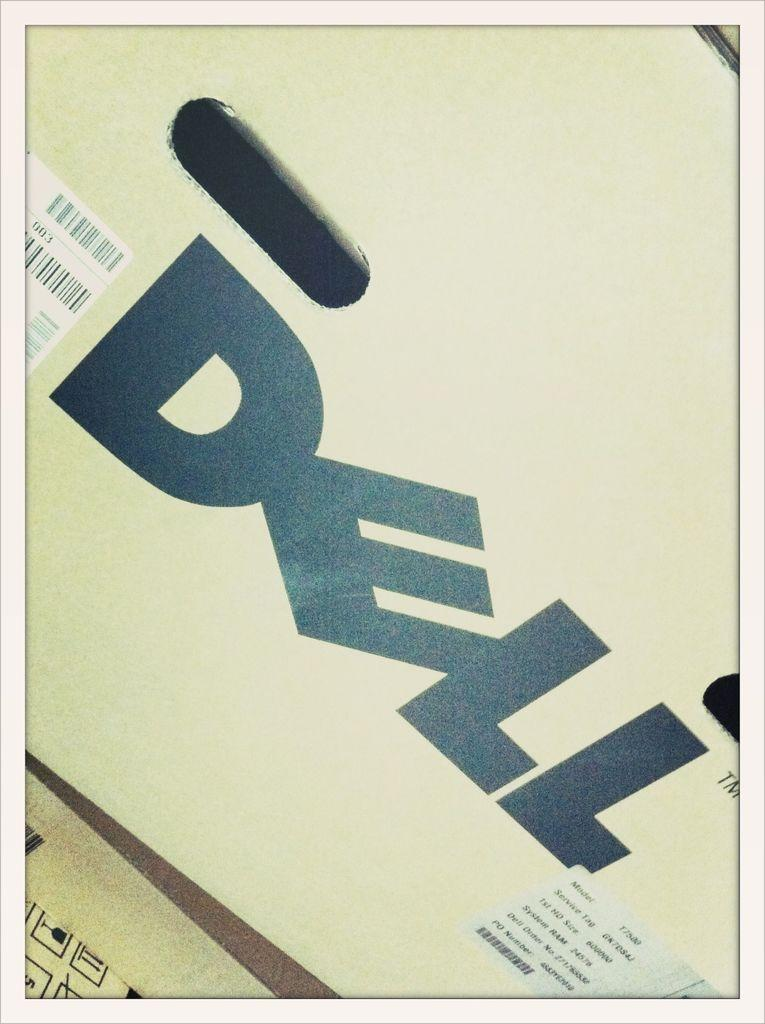What type of material is used for the sheets in the image? The sheets in the image are made of cardboard. What can be found on the cardboard sheets? The cardboard sheets have symbols, text, and stickers on them. Can you tell me how many airports are depicted on the cardboard sheets? There are no airports depicted on the cardboard sheets; they have symbols, text, and stickers on them. Does the existence of the cardboard sheets prove the existence of a specific object or concept? The existence of the cardboard sheets does not prove the existence of any specific object or concept beyond the sheets themselves. 